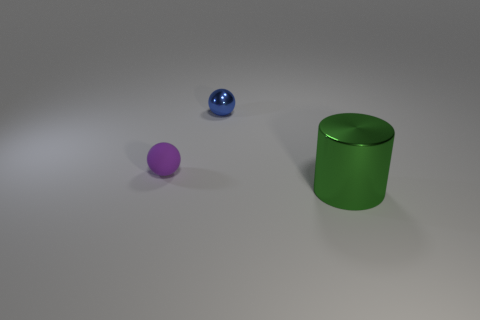Are there any other things that are the same material as the small purple thing?
Provide a short and direct response. No. How many small spheres are right of the small ball that is in front of the shiny thing behind the cylinder?
Your answer should be very brief. 1. Does the object that is right of the small blue sphere have the same material as the ball that is to the right of the tiny purple matte ball?
Your answer should be compact. Yes. What number of small purple objects have the same shape as the green thing?
Provide a succinct answer. 0. Are there more rubber objects that are on the left side of the blue metallic sphere than tiny red matte cylinders?
Ensure brevity in your answer.  Yes. There is a metal object that is behind the ball left of the shiny object to the left of the cylinder; what shape is it?
Your answer should be very brief. Sphere. Do the metal thing that is behind the green metallic object and the metallic thing that is to the right of the blue metallic thing have the same shape?
Offer a terse response. No. Is there any other thing that is the same size as the green object?
Ensure brevity in your answer.  No. How many cylinders are tiny gray objects or blue things?
Provide a short and direct response. 0. Does the blue thing have the same material as the green cylinder?
Your response must be concise. Yes. 